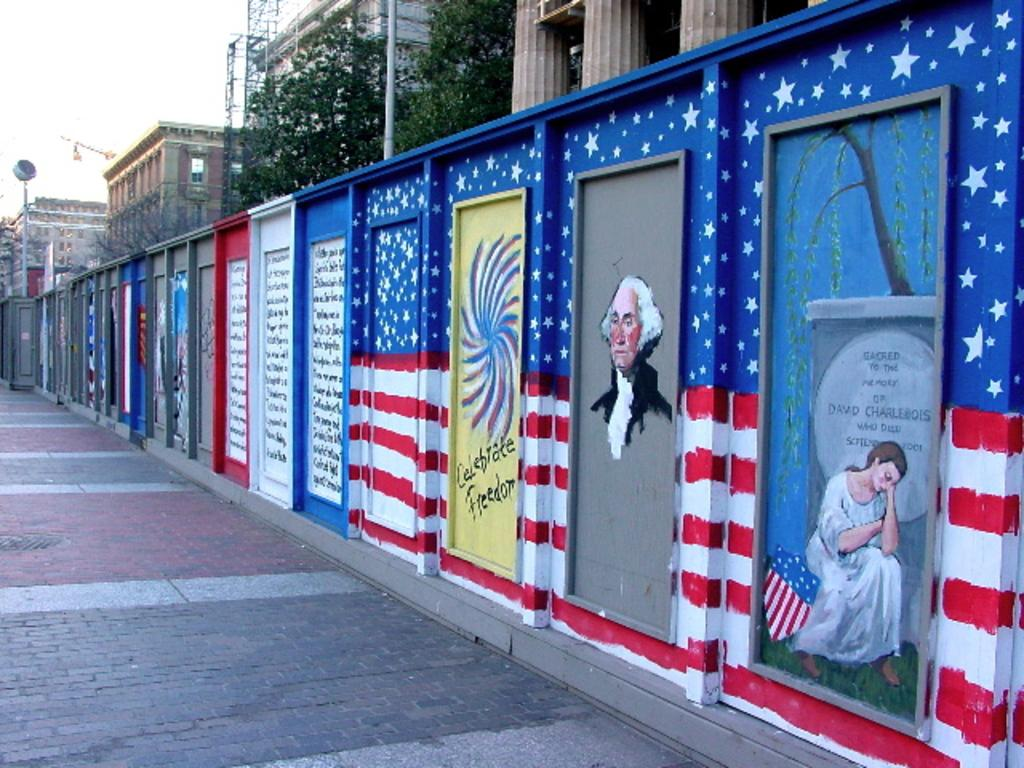What type of surface is visible in the image? There is a sidewalk in the image. What structure is present near the sidewalk? There is a wall in the image. What decorates the wall in the image? There are paintings on the wall. What type of vegetation is near the wall? There are trees near the wall. What type of structures can be seen in the image? There are buildings in the image. What is visible in the background of the image? The sky is visible in the background of the image. How many cabbages are hanging from the wall in the image? There are no cabbages present in the image; the wall features paintings instead. What type of creature is depicted in the paintings on the wall? The paintings on the wall cannot be definitively described without more information about their content, but there is no mention of a crow in the provided facts. 